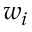<formula> <loc_0><loc_0><loc_500><loc_500>w _ { i }</formula> 